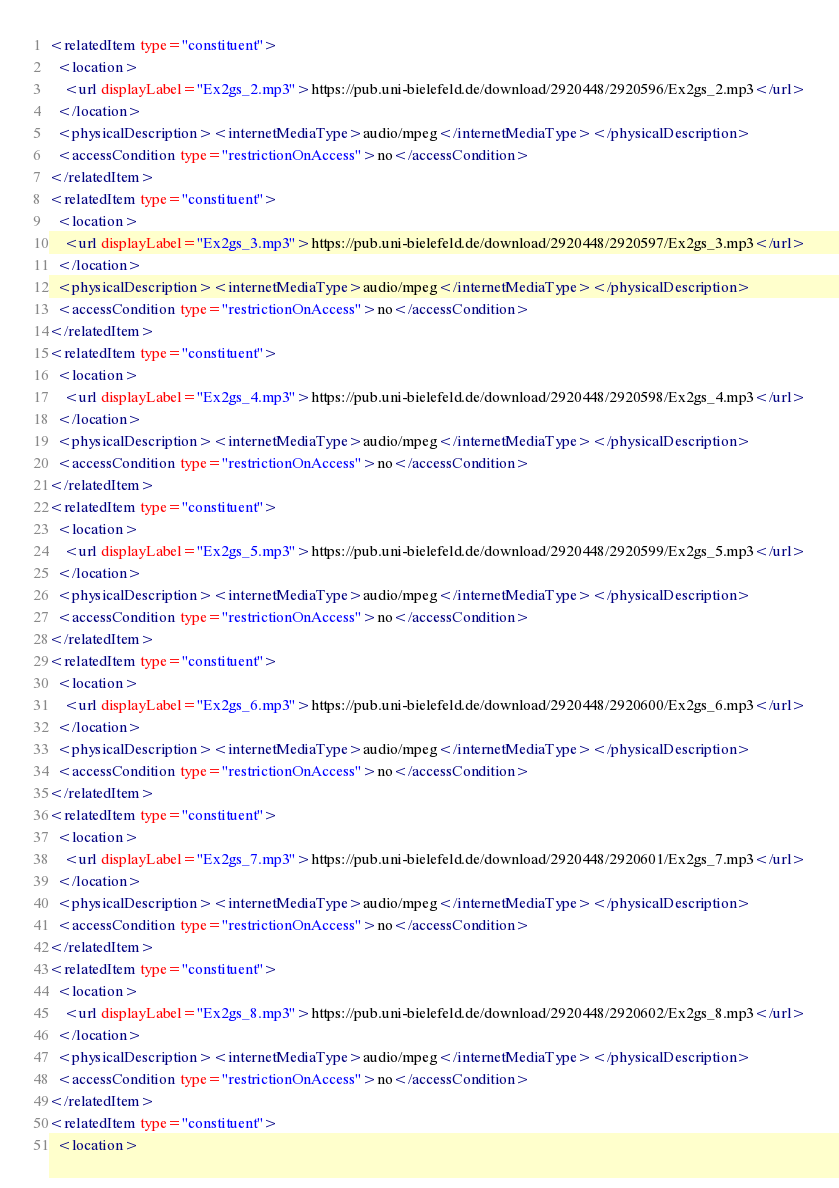Convert code to text. <code><loc_0><loc_0><loc_500><loc_500><_XML_><relatedItem type="constituent">
  <location>
    <url displayLabel="Ex2gs_2.mp3">https://pub.uni-bielefeld.de/download/2920448/2920596/Ex2gs_2.mp3</url>
  </location>
  <physicalDescription><internetMediaType>audio/mpeg</internetMediaType></physicalDescription>
  <accessCondition type="restrictionOnAccess">no</accessCondition>
</relatedItem>
<relatedItem type="constituent">
  <location>
    <url displayLabel="Ex2gs_3.mp3">https://pub.uni-bielefeld.de/download/2920448/2920597/Ex2gs_3.mp3</url>
  </location>
  <physicalDescription><internetMediaType>audio/mpeg</internetMediaType></physicalDescription>
  <accessCondition type="restrictionOnAccess">no</accessCondition>
</relatedItem>
<relatedItem type="constituent">
  <location>
    <url displayLabel="Ex2gs_4.mp3">https://pub.uni-bielefeld.de/download/2920448/2920598/Ex2gs_4.mp3</url>
  </location>
  <physicalDescription><internetMediaType>audio/mpeg</internetMediaType></physicalDescription>
  <accessCondition type="restrictionOnAccess">no</accessCondition>
</relatedItem>
<relatedItem type="constituent">
  <location>
    <url displayLabel="Ex2gs_5.mp3">https://pub.uni-bielefeld.de/download/2920448/2920599/Ex2gs_5.mp3</url>
  </location>
  <physicalDescription><internetMediaType>audio/mpeg</internetMediaType></physicalDescription>
  <accessCondition type="restrictionOnAccess">no</accessCondition>
</relatedItem>
<relatedItem type="constituent">
  <location>
    <url displayLabel="Ex2gs_6.mp3">https://pub.uni-bielefeld.de/download/2920448/2920600/Ex2gs_6.mp3</url>
  </location>
  <physicalDescription><internetMediaType>audio/mpeg</internetMediaType></physicalDescription>
  <accessCondition type="restrictionOnAccess">no</accessCondition>
</relatedItem>
<relatedItem type="constituent">
  <location>
    <url displayLabel="Ex2gs_7.mp3">https://pub.uni-bielefeld.de/download/2920448/2920601/Ex2gs_7.mp3</url>
  </location>
  <physicalDescription><internetMediaType>audio/mpeg</internetMediaType></physicalDescription>
  <accessCondition type="restrictionOnAccess">no</accessCondition>
</relatedItem>
<relatedItem type="constituent">
  <location>
    <url displayLabel="Ex2gs_8.mp3">https://pub.uni-bielefeld.de/download/2920448/2920602/Ex2gs_8.mp3</url>
  </location>
  <physicalDescription><internetMediaType>audio/mpeg</internetMediaType></physicalDescription>
  <accessCondition type="restrictionOnAccess">no</accessCondition>
</relatedItem>
<relatedItem type="constituent">
  <location></code> 